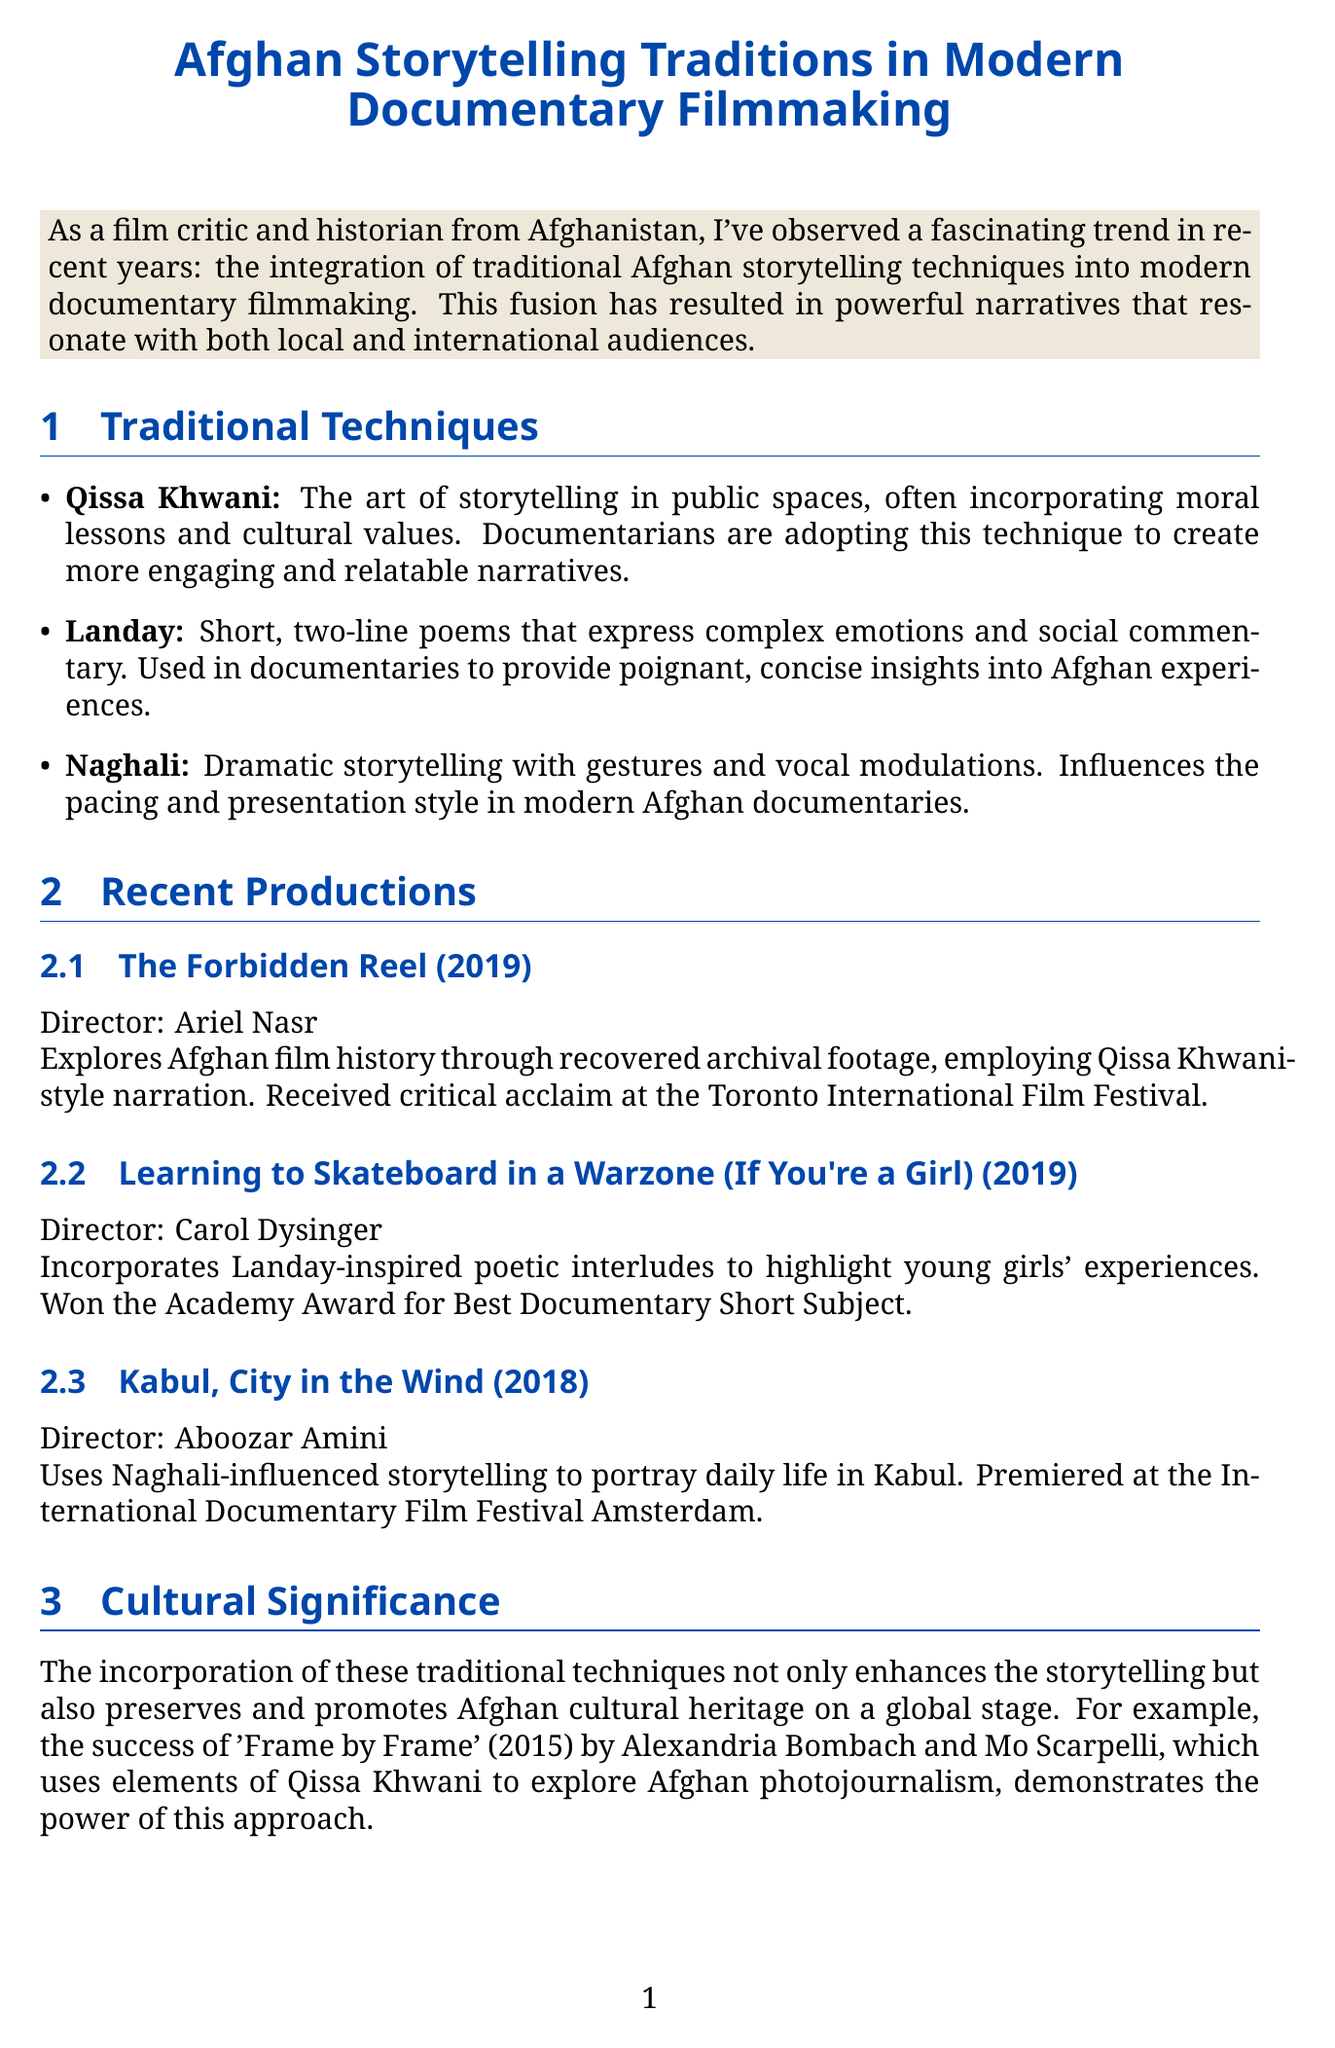What is the title of the newsletter? The title is stated at the beginning of the document.
Answer: Afghan Storytelling Traditions in Modern Documentary Filmmaking Who directed "The Forbidden Reel"? The director of the documentary is mentioned in the recent productions section.
Answer: Ariel Nasr In what year was "Learning to Skateboard in a Warzone (If You're a Girl)" released? The release year is provided alongside each documentary title.
Answer: 2019 What storytelling technique is characterized by short, two-line poems? The document lists various traditional techniques, including their specific characteristics.
Answer: Landay Which film won the Academy Award for Best Documentary Short Subject? The impact section mentions the accolades of recent documentaries.
Answer: Learning to Skateboard in a Warzone (If You're a Girl) What is one challenge mentioned that filmmakers face? The challenges section lists specific issues regarding traditional and modern practices.
Answer: Balancing traditional techniques with modern filmmaking conventions What is one potential trend for the future of Afghan documentaries? Future prospects section discusses what might be expected in upcoming films.
Answer: Increased use of interactive and immersive technologies What narrative style is used in "The Forbidden Reel" to explore film history? The description of the documentary specifies the style employed by the filmmaker.
Answer: Qissa Khwani-style narration 